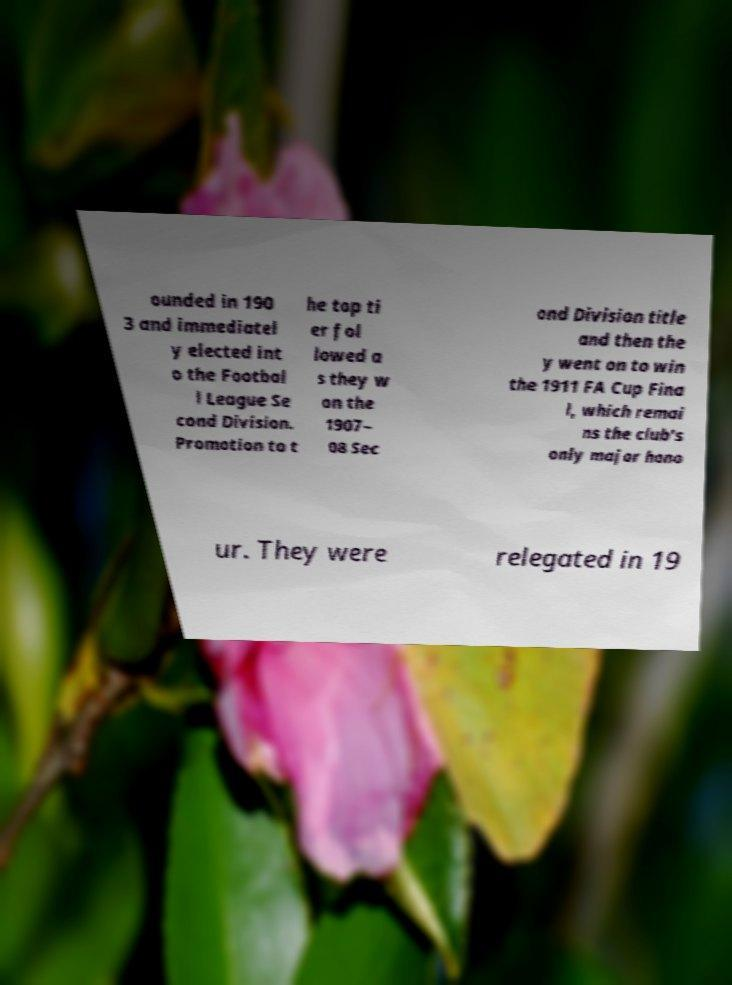Could you extract and type out the text from this image? ounded in 190 3 and immediatel y elected int o the Footbal l League Se cond Division. Promotion to t he top ti er fol lowed a s they w on the 1907– 08 Sec ond Division title and then the y went on to win the 1911 FA Cup Fina l, which remai ns the club's only major hono ur. They were relegated in 19 